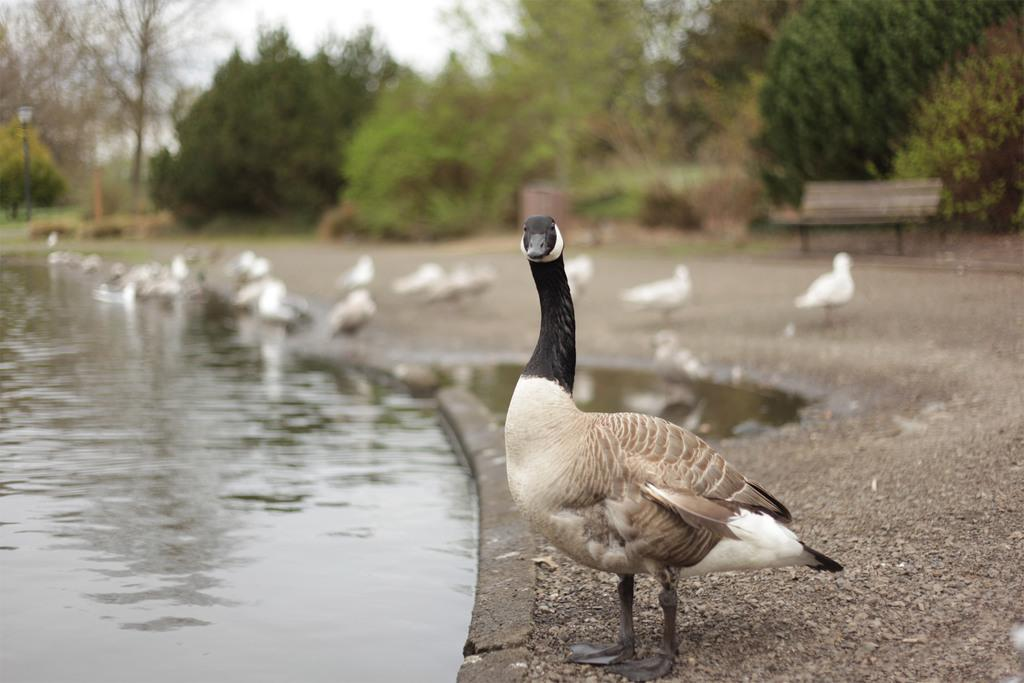What animal is standing in the image? There is a duck standing in the image. What type of environment is depicted in the image? The image appears to depict a pond with water flowing. Are there any other ducks visible in the image? Yes, there are additional ducks visible in the background of the image. What type of seating is present in the image? There is a bench in the image. What type of vegetation is present in the background of the image? Trees are present in the background of the image. What type of punishment is being administered to the sheep in the image? There is no sheep present in the image, so no punishment can be observed. 